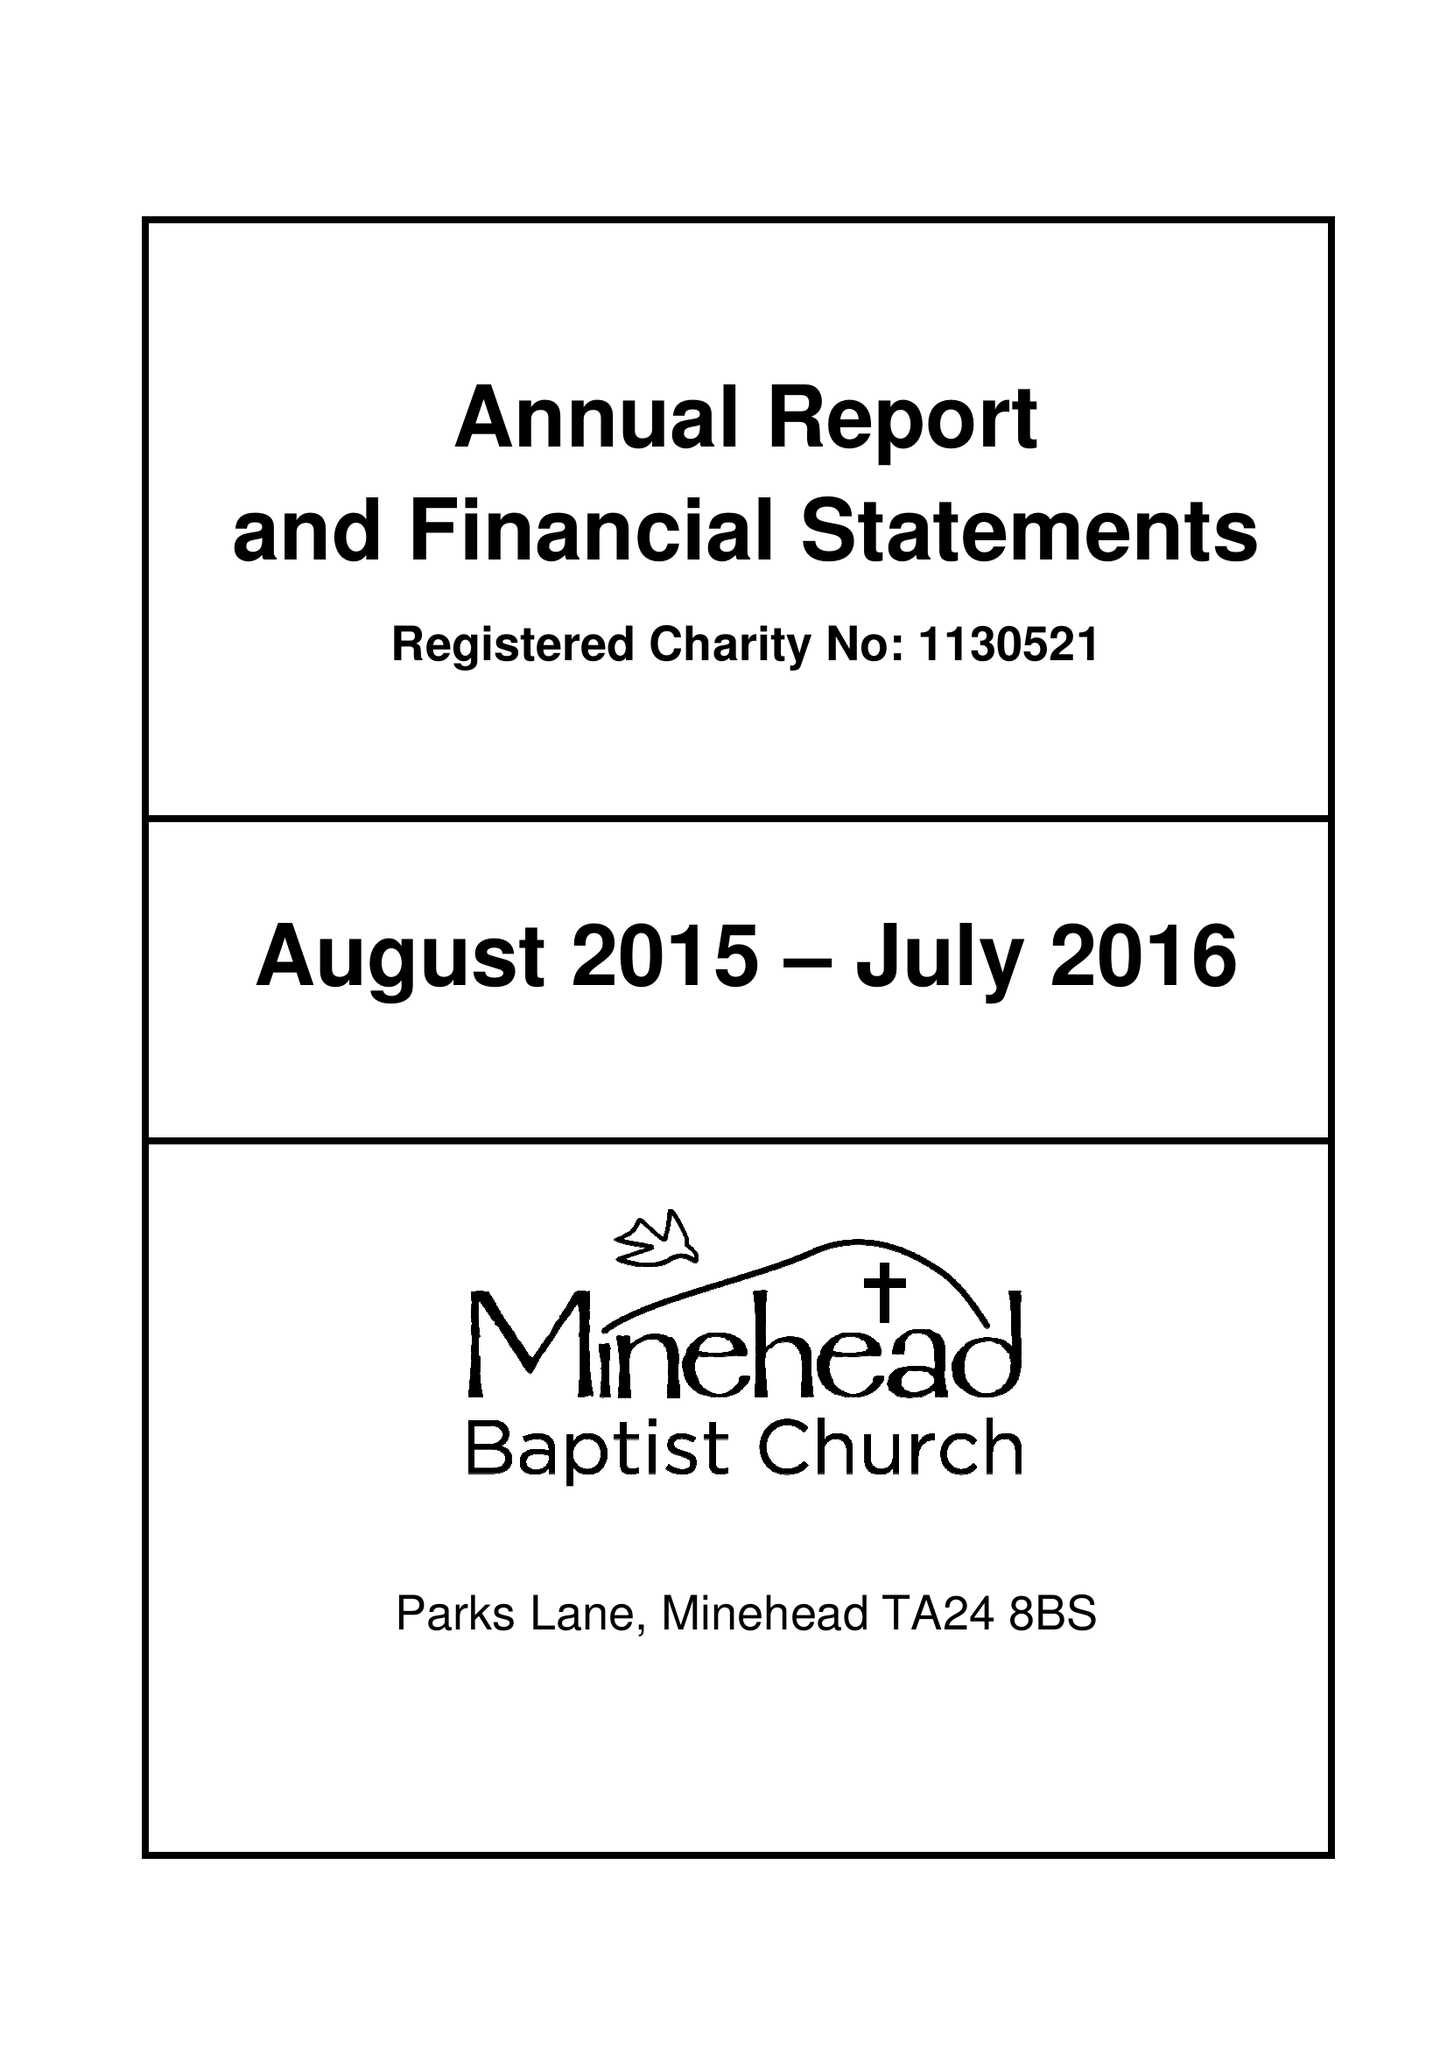What is the value for the address__post_town?
Answer the question using a single word or phrase. MINEHEAD 